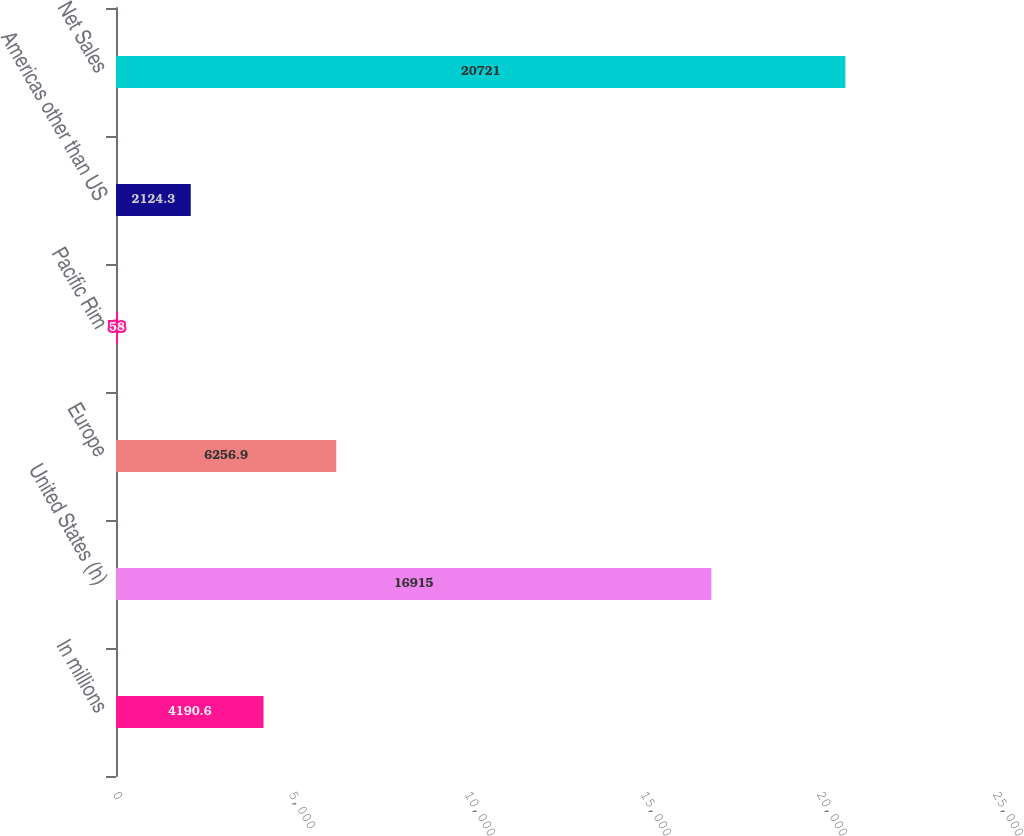Convert chart. <chart><loc_0><loc_0><loc_500><loc_500><bar_chart><fcel>In millions<fcel>United States (h)<fcel>Europe<fcel>Pacific Rim<fcel>Americas other than US<fcel>Net Sales<nl><fcel>4190.6<fcel>16915<fcel>6256.9<fcel>58<fcel>2124.3<fcel>20721<nl></chart> 